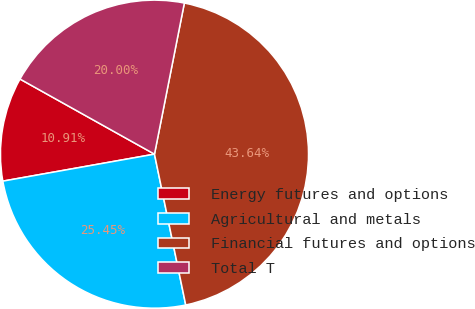Convert chart to OTSL. <chart><loc_0><loc_0><loc_500><loc_500><pie_chart><fcel>Energy futures and options<fcel>Agricultural and metals<fcel>Financial futures and options<fcel>Total T<nl><fcel>10.91%<fcel>25.45%<fcel>43.64%<fcel>20.0%<nl></chart> 